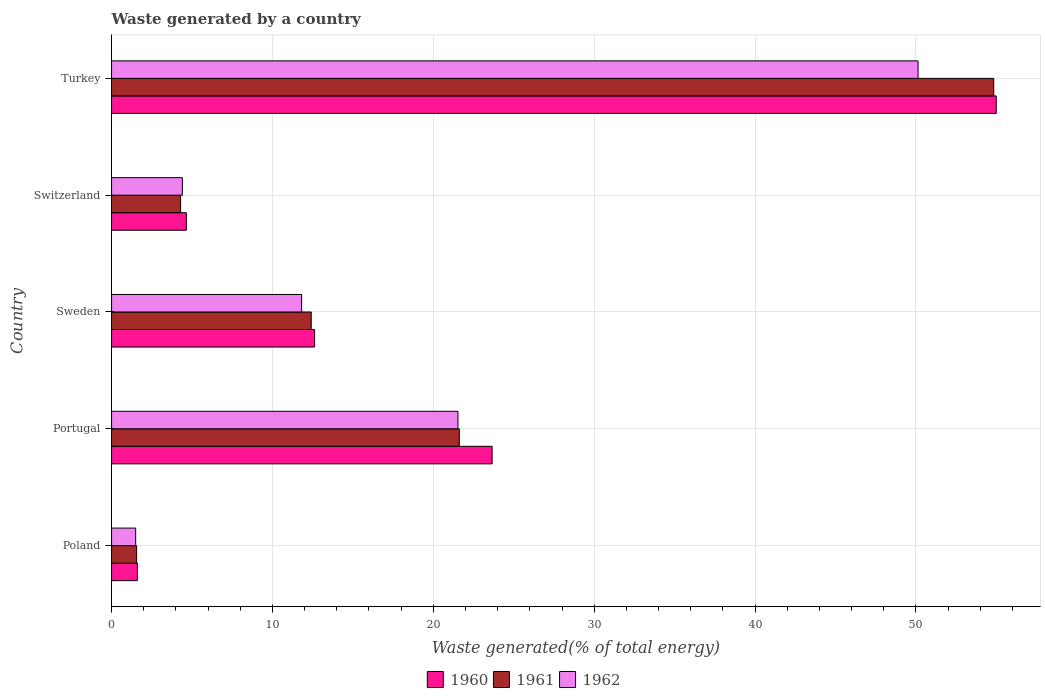How many groups of bars are there?
Your answer should be very brief. 5. Are the number of bars on each tick of the Y-axis equal?
Ensure brevity in your answer.  Yes. What is the label of the 4th group of bars from the top?
Provide a succinct answer. Portugal. What is the total waste generated in 1962 in Turkey?
Give a very brief answer. 50.13. Across all countries, what is the maximum total waste generated in 1961?
Make the answer very short. 54.84. Across all countries, what is the minimum total waste generated in 1962?
Your response must be concise. 1.5. In which country was the total waste generated in 1960 minimum?
Make the answer very short. Poland. What is the total total waste generated in 1962 in the graph?
Make the answer very short. 89.39. What is the difference between the total waste generated in 1962 in Portugal and that in Turkey?
Keep it short and to the point. -28.6. What is the difference between the total waste generated in 1961 in Portugal and the total waste generated in 1962 in Sweden?
Your answer should be very brief. 9.8. What is the average total waste generated in 1960 per country?
Give a very brief answer. 19.51. What is the difference between the total waste generated in 1961 and total waste generated in 1960 in Switzerland?
Keep it short and to the point. -0.36. In how many countries, is the total waste generated in 1962 greater than 48 %?
Ensure brevity in your answer.  1. What is the ratio of the total waste generated in 1960 in Switzerland to that in Turkey?
Offer a very short reply. 0.08. Is the total waste generated in 1961 in Poland less than that in Sweden?
Keep it short and to the point. Yes. Is the difference between the total waste generated in 1961 in Poland and Turkey greater than the difference between the total waste generated in 1960 in Poland and Turkey?
Your answer should be very brief. Yes. What is the difference between the highest and the second highest total waste generated in 1960?
Give a very brief answer. 31.34. What is the difference between the highest and the lowest total waste generated in 1960?
Provide a succinct answer. 53.39. What does the 1st bar from the top in Turkey represents?
Your answer should be very brief. 1962. What does the 3rd bar from the bottom in Portugal represents?
Provide a short and direct response. 1962. How many bars are there?
Give a very brief answer. 15. Are all the bars in the graph horizontal?
Make the answer very short. Yes. What is the difference between two consecutive major ticks on the X-axis?
Offer a terse response. 10. Are the values on the major ticks of X-axis written in scientific E-notation?
Make the answer very short. No. Does the graph contain grids?
Your answer should be very brief. Yes. How many legend labels are there?
Make the answer very short. 3. What is the title of the graph?
Give a very brief answer. Waste generated by a country. Does "1978" appear as one of the legend labels in the graph?
Provide a short and direct response. No. What is the label or title of the X-axis?
Provide a short and direct response. Waste generated(% of total energy). What is the Waste generated(% of total energy) of 1960 in Poland?
Your answer should be very brief. 1.6. What is the Waste generated(% of total energy) of 1961 in Poland?
Your answer should be very brief. 1.56. What is the Waste generated(% of total energy) in 1962 in Poland?
Your answer should be compact. 1.5. What is the Waste generated(% of total energy) of 1960 in Portugal?
Keep it short and to the point. 23.66. What is the Waste generated(% of total energy) of 1961 in Portugal?
Your answer should be compact. 21.62. What is the Waste generated(% of total energy) of 1962 in Portugal?
Give a very brief answer. 21.53. What is the Waste generated(% of total energy) in 1960 in Sweden?
Keep it short and to the point. 12.62. What is the Waste generated(% of total energy) of 1961 in Sweden?
Offer a very short reply. 12.41. What is the Waste generated(% of total energy) of 1962 in Sweden?
Your response must be concise. 11.82. What is the Waste generated(% of total energy) in 1960 in Switzerland?
Your answer should be very brief. 4.65. What is the Waste generated(% of total energy) in 1961 in Switzerland?
Your response must be concise. 4.29. What is the Waste generated(% of total energy) in 1962 in Switzerland?
Offer a very short reply. 4.4. What is the Waste generated(% of total energy) of 1960 in Turkey?
Keep it short and to the point. 54.99. What is the Waste generated(% of total energy) in 1961 in Turkey?
Offer a very short reply. 54.84. What is the Waste generated(% of total energy) of 1962 in Turkey?
Make the answer very short. 50.13. Across all countries, what is the maximum Waste generated(% of total energy) of 1960?
Provide a short and direct response. 54.99. Across all countries, what is the maximum Waste generated(% of total energy) in 1961?
Provide a short and direct response. 54.84. Across all countries, what is the maximum Waste generated(% of total energy) in 1962?
Ensure brevity in your answer.  50.13. Across all countries, what is the minimum Waste generated(% of total energy) of 1960?
Keep it short and to the point. 1.6. Across all countries, what is the minimum Waste generated(% of total energy) in 1961?
Offer a terse response. 1.56. Across all countries, what is the minimum Waste generated(% of total energy) in 1962?
Provide a short and direct response. 1.5. What is the total Waste generated(% of total energy) of 1960 in the graph?
Your answer should be compact. 97.53. What is the total Waste generated(% of total energy) of 1961 in the graph?
Offer a terse response. 94.72. What is the total Waste generated(% of total energy) in 1962 in the graph?
Ensure brevity in your answer.  89.39. What is the difference between the Waste generated(% of total energy) of 1960 in Poland and that in Portugal?
Your answer should be compact. -22.05. What is the difference between the Waste generated(% of total energy) in 1961 in Poland and that in Portugal?
Your answer should be very brief. -20.06. What is the difference between the Waste generated(% of total energy) in 1962 in Poland and that in Portugal?
Ensure brevity in your answer.  -20.03. What is the difference between the Waste generated(% of total energy) of 1960 in Poland and that in Sweden?
Give a very brief answer. -11.02. What is the difference between the Waste generated(% of total energy) of 1961 in Poland and that in Sweden?
Keep it short and to the point. -10.85. What is the difference between the Waste generated(% of total energy) in 1962 in Poland and that in Sweden?
Provide a succinct answer. -10.32. What is the difference between the Waste generated(% of total energy) of 1960 in Poland and that in Switzerland?
Your response must be concise. -3.04. What is the difference between the Waste generated(% of total energy) in 1961 in Poland and that in Switzerland?
Make the answer very short. -2.73. What is the difference between the Waste generated(% of total energy) in 1962 in Poland and that in Switzerland?
Ensure brevity in your answer.  -2.9. What is the difference between the Waste generated(% of total energy) in 1960 in Poland and that in Turkey?
Give a very brief answer. -53.39. What is the difference between the Waste generated(% of total energy) of 1961 in Poland and that in Turkey?
Your answer should be very brief. -53.28. What is the difference between the Waste generated(% of total energy) of 1962 in Poland and that in Turkey?
Keep it short and to the point. -48.64. What is the difference between the Waste generated(% of total energy) of 1960 in Portugal and that in Sweden?
Offer a terse response. 11.03. What is the difference between the Waste generated(% of total energy) of 1961 in Portugal and that in Sweden?
Your answer should be compact. 9.2. What is the difference between the Waste generated(% of total energy) in 1962 in Portugal and that in Sweden?
Provide a succinct answer. 9.72. What is the difference between the Waste generated(% of total energy) in 1960 in Portugal and that in Switzerland?
Offer a terse response. 19.01. What is the difference between the Waste generated(% of total energy) in 1961 in Portugal and that in Switzerland?
Your answer should be very brief. 17.32. What is the difference between the Waste generated(% of total energy) of 1962 in Portugal and that in Switzerland?
Provide a short and direct response. 17.13. What is the difference between the Waste generated(% of total energy) in 1960 in Portugal and that in Turkey?
Provide a short and direct response. -31.34. What is the difference between the Waste generated(% of total energy) of 1961 in Portugal and that in Turkey?
Provide a succinct answer. -33.22. What is the difference between the Waste generated(% of total energy) in 1962 in Portugal and that in Turkey?
Your answer should be very brief. -28.6. What is the difference between the Waste generated(% of total energy) in 1960 in Sweden and that in Switzerland?
Give a very brief answer. 7.97. What is the difference between the Waste generated(% of total energy) of 1961 in Sweden and that in Switzerland?
Ensure brevity in your answer.  8.12. What is the difference between the Waste generated(% of total energy) in 1962 in Sweden and that in Switzerland?
Your response must be concise. 7.41. What is the difference between the Waste generated(% of total energy) in 1960 in Sweden and that in Turkey?
Offer a terse response. -42.37. What is the difference between the Waste generated(% of total energy) of 1961 in Sweden and that in Turkey?
Keep it short and to the point. -42.43. What is the difference between the Waste generated(% of total energy) in 1962 in Sweden and that in Turkey?
Ensure brevity in your answer.  -38.32. What is the difference between the Waste generated(% of total energy) of 1960 in Switzerland and that in Turkey?
Your answer should be compact. -50.34. What is the difference between the Waste generated(% of total energy) of 1961 in Switzerland and that in Turkey?
Give a very brief answer. -50.55. What is the difference between the Waste generated(% of total energy) of 1962 in Switzerland and that in Turkey?
Your answer should be very brief. -45.73. What is the difference between the Waste generated(% of total energy) in 1960 in Poland and the Waste generated(% of total energy) in 1961 in Portugal?
Your answer should be compact. -20.01. What is the difference between the Waste generated(% of total energy) of 1960 in Poland and the Waste generated(% of total energy) of 1962 in Portugal?
Ensure brevity in your answer.  -19.93. What is the difference between the Waste generated(% of total energy) of 1961 in Poland and the Waste generated(% of total energy) of 1962 in Portugal?
Provide a succinct answer. -19.98. What is the difference between the Waste generated(% of total energy) of 1960 in Poland and the Waste generated(% of total energy) of 1961 in Sweden?
Your answer should be compact. -10.81. What is the difference between the Waste generated(% of total energy) of 1960 in Poland and the Waste generated(% of total energy) of 1962 in Sweden?
Offer a terse response. -10.21. What is the difference between the Waste generated(% of total energy) in 1961 in Poland and the Waste generated(% of total energy) in 1962 in Sweden?
Provide a succinct answer. -10.26. What is the difference between the Waste generated(% of total energy) in 1960 in Poland and the Waste generated(% of total energy) in 1961 in Switzerland?
Your answer should be very brief. -2.69. What is the difference between the Waste generated(% of total energy) in 1960 in Poland and the Waste generated(% of total energy) in 1962 in Switzerland?
Ensure brevity in your answer.  -2.8. What is the difference between the Waste generated(% of total energy) of 1961 in Poland and the Waste generated(% of total energy) of 1962 in Switzerland?
Provide a succinct answer. -2.84. What is the difference between the Waste generated(% of total energy) of 1960 in Poland and the Waste generated(% of total energy) of 1961 in Turkey?
Ensure brevity in your answer.  -53.23. What is the difference between the Waste generated(% of total energy) in 1960 in Poland and the Waste generated(% of total energy) in 1962 in Turkey?
Give a very brief answer. -48.53. What is the difference between the Waste generated(% of total energy) in 1961 in Poland and the Waste generated(% of total energy) in 1962 in Turkey?
Keep it short and to the point. -48.58. What is the difference between the Waste generated(% of total energy) in 1960 in Portugal and the Waste generated(% of total energy) in 1961 in Sweden?
Provide a short and direct response. 11.24. What is the difference between the Waste generated(% of total energy) of 1960 in Portugal and the Waste generated(% of total energy) of 1962 in Sweden?
Keep it short and to the point. 11.84. What is the difference between the Waste generated(% of total energy) of 1961 in Portugal and the Waste generated(% of total energy) of 1962 in Sweden?
Keep it short and to the point. 9.8. What is the difference between the Waste generated(% of total energy) in 1960 in Portugal and the Waste generated(% of total energy) in 1961 in Switzerland?
Make the answer very short. 19.36. What is the difference between the Waste generated(% of total energy) in 1960 in Portugal and the Waste generated(% of total energy) in 1962 in Switzerland?
Provide a short and direct response. 19.25. What is the difference between the Waste generated(% of total energy) of 1961 in Portugal and the Waste generated(% of total energy) of 1962 in Switzerland?
Your answer should be very brief. 17.21. What is the difference between the Waste generated(% of total energy) of 1960 in Portugal and the Waste generated(% of total energy) of 1961 in Turkey?
Provide a short and direct response. -31.18. What is the difference between the Waste generated(% of total energy) of 1960 in Portugal and the Waste generated(% of total energy) of 1962 in Turkey?
Make the answer very short. -26.48. What is the difference between the Waste generated(% of total energy) in 1961 in Portugal and the Waste generated(% of total energy) in 1962 in Turkey?
Provide a succinct answer. -28.52. What is the difference between the Waste generated(% of total energy) in 1960 in Sweden and the Waste generated(% of total energy) in 1961 in Switzerland?
Provide a short and direct response. 8.33. What is the difference between the Waste generated(% of total energy) of 1960 in Sweden and the Waste generated(% of total energy) of 1962 in Switzerland?
Your answer should be very brief. 8.22. What is the difference between the Waste generated(% of total energy) in 1961 in Sweden and the Waste generated(% of total energy) in 1962 in Switzerland?
Provide a short and direct response. 8.01. What is the difference between the Waste generated(% of total energy) in 1960 in Sweden and the Waste generated(% of total energy) in 1961 in Turkey?
Your response must be concise. -42.22. What is the difference between the Waste generated(% of total energy) of 1960 in Sweden and the Waste generated(% of total energy) of 1962 in Turkey?
Provide a succinct answer. -37.51. What is the difference between the Waste generated(% of total energy) in 1961 in Sweden and the Waste generated(% of total energy) in 1962 in Turkey?
Make the answer very short. -37.72. What is the difference between the Waste generated(% of total energy) in 1960 in Switzerland and the Waste generated(% of total energy) in 1961 in Turkey?
Provide a short and direct response. -50.19. What is the difference between the Waste generated(% of total energy) of 1960 in Switzerland and the Waste generated(% of total energy) of 1962 in Turkey?
Provide a short and direct response. -45.48. What is the difference between the Waste generated(% of total energy) in 1961 in Switzerland and the Waste generated(% of total energy) in 1962 in Turkey?
Offer a very short reply. -45.84. What is the average Waste generated(% of total energy) in 1960 per country?
Your answer should be compact. 19.51. What is the average Waste generated(% of total energy) of 1961 per country?
Your answer should be compact. 18.94. What is the average Waste generated(% of total energy) of 1962 per country?
Your response must be concise. 17.88. What is the difference between the Waste generated(% of total energy) in 1960 and Waste generated(% of total energy) in 1961 in Poland?
Provide a short and direct response. 0.05. What is the difference between the Waste generated(% of total energy) of 1960 and Waste generated(% of total energy) of 1962 in Poland?
Keep it short and to the point. 0.11. What is the difference between the Waste generated(% of total energy) in 1961 and Waste generated(% of total energy) in 1962 in Poland?
Your response must be concise. 0.06. What is the difference between the Waste generated(% of total energy) of 1960 and Waste generated(% of total energy) of 1961 in Portugal?
Make the answer very short. 2.04. What is the difference between the Waste generated(% of total energy) in 1960 and Waste generated(% of total energy) in 1962 in Portugal?
Offer a terse response. 2.12. What is the difference between the Waste generated(% of total energy) of 1961 and Waste generated(% of total energy) of 1962 in Portugal?
Provide a short and direct response. 0.08. What is the difference between the Waste generated(% of total energy) in 1960 and Waste generated(% of total energy) in 1961 in Sweden?
Offer a very short reply. 0.21. What is the difference between the Waste generated(% of total energy) of 1960 and Waste generated(% of total energy) of 1962 in Sweden?
Ensure brevity in your answer.  0.81. What is the difference between the Waste generated(% of total energy) in 1961 and Waste generated(% of total energy) in 1962 in Sweden?
Your answer should be compact. 0.6. What is the difference between the Waste generated(% of total energy) of 1960 and Waste generated(% of total energy) of 1961 in Switzerland?
Ensure brevity in your answer.  0.36. What is the difference between the Waste generated(% of total energy) in 1960 and Waste generated(% of total energy) in 1962 in Switzerland?
Offer a very short reply. 0.25. What is the difference between the Waste generated(% of total energy) of 1961 and Waste generated(% of total energy) of 1962 in Switzerland?
Keep it short and to the point. -0.11. What is the difference between the Waste generated(% of total energy) of 1960 and Waste generated(% of total energy) of 1961 in Turkey?
Make the answer very short. 0.16. What is the difference between the Waste generated(% of total energy) in 1960 and Waste generated(% of total energy) in 1962 in Turkey?
Your answer should be compact. 4.86. What is the difference between the Waste generated(% of total energy) of 1961 and Waste generated(% of total energy) of 1962 in Turkey?
Provide a short and direct response. 4.7. What is the ratio of the Waste generated(% of total energy) in 1960 in Poland to that in Portugal?
Keep it short and to the point. 0.07. What is the ratio of the Waste generated(% of total energy) in 1961 in Poland to that in Portugal?
Provide a succinct answer. 0.07. What is the ratio of the Waste generated(% of total energy) of 1962 in Poland to that in Portugal?
Keep it short and to the point. 0.07. What is the ratio of the Waste generated(% of total energy) of 1960 in Poland to that in Sweden?
Your answer should be compact. 0.13. What is the ratio of the Waste generated(% of total energy) of 1961 in Poland to that in Sweden?
Your answer should be compact. 0.13. What is the ratio of the Waste generated(% of total energy) in 1962 in Poland to that in Sweden?
Offer a terse response. 0.13. What is the ratio of the Waste generated(% of total energy) in 1960 in Poland to that in Switzerland?
Give a very brief answer. 0.35. What is the ratio of the Waste generated(% of total energy) in 1961 in Poland to that in Switzerland?
Offer a very short reply. 0.36. What is the ratio of the Waste generated(% of total energy) in 1962 in Poland to that in Switzerland?
Ensure brevity in your answer.  0.34. What is the ratio of the Waste generated(% of total energy) in 1960 in Poland to that in Turkey?
Give a very brief answer. 0.03. What is the ratio of the Waste generated(% of total energy) in 1961 in Poland to that in Turkey?
Your answer should be compact. 0.03. What is the ratio of the Waste generated(% of total energy) of 1962 in Poland to that in Turkey?
Provide a short and direct response. 0.03. What is the ratio of the Waste generated(% of total energy) of 1960 in Portugal to that in Sweden?
Provide a short and direct response. 1.87. What is the ratio of the Waste generated(% of total energy) in 1961 in Portugal to that in Sweden?
Ensure brevity in your answer.  1.74. What is the ratio of the Waste generated(% of total energy) of 1962 in Portugal to that in Sweden?
Make the answer very short. 1.82. What is the ratio of the Waste generated(% of total energy) in 1960 in Portugal to that in Switzerland?
Provide a short and direct response. 5.09. What is the ratio of the Waste generated(% of total energy) of 1961 in Portugal to that in Switzerland?
Offer a very short reply. 5.04. What is the ratio of the Waste generated(% of total energy) in 1962 in Portugal to that in Switzerland?
Your answer should be compact. 4.89. What is the ratio of the Waste generated(% of total energy) in 1960 in Portugal to that in Turkey?
Offer a terse response. 0.43. What is the ratio of the Waste generated(% of total energy) of 1961 in Portugal to that in Turkey?
Give a very brief answer. 0.39. What is the ratio of the Waste generated(% of total energy) of 1962 in Portugal to that in Turkey?
Offer a terse response. 0.43. What is the ratio of the Waste generated(% of total energy) in 1960 in Sweden to that in Switzerland?
Offer a very short reply. 2.71. What is the ratio of the Waste generated(% of total energy) in 1961 in Sweden to that in Switzerland?
Offer a terse response. 2.89. What is the ratio of the Waste generated(% of total energy) of 1962 in Sweden to that in Switzerland?
Your response must be concise. 2.68. What is the ratio of the Waste generated(% of total energy) of 1960 in Sweden to that in Turkey?
Ensure brevity in your answer.  0.23. What is the ratio of the Waste generated(% of total energy) in 1961 in Sweden to that in Turkey?
Your answer should be very brief. 0.23. What is the ratio of the Waste generated(% of total energy) of 1962 in Sweden to that in Turkey?
Your response must be concise. 0.24. What is the ratio of the Waste generated(% of total energy) in 1960 in Switzerland to that in Turkey?
Provide a succinct answer. 0.08. What is the ratio of the Waste generated(% of total energy) in 1961 in Switzerland to that in Turkey?
Your response must be concise. 0.08. What is the ratio of the Waste generated(% of total energy) in 1962 in Switzerland to that in Turkey?
Offer a terse response. 0.09. What is the difference between the highest and the second highest Waste generated(% of total energy) in 1960?
Keep it short and to the point. 31.34. What is the difference between the highest and the second highest Waste generated(% of total energy) in 1961?
Your answer should be compact. 33.22. What is the difference between the highest and the second highest Waste generated(% of total energy) in 1962?
Make the answer very short. 28.6. What is the difference between the highest and the lowest Waste generated(% of total energy) of 1960?
Your answer should be compact. 53.39. What is the difference between the highest and the lowest Waste generated(% of total energy) of 1961?
Keep it short and to the point. 53.28. What is the difference between the highest and the lowest Waste generated(% of total energy) of 1962?
Provide a short and direct response. 48.64. 